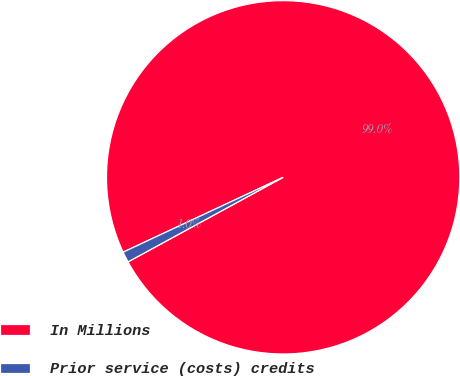Convert chart. <chart><loc_0><loc_0><loc_500><loc_500><pie_chart><fcel>In Millions<fcel>Prior service (costs) credits<nl><fcel>99.02%<fcel>0.98%<nl></chart> 